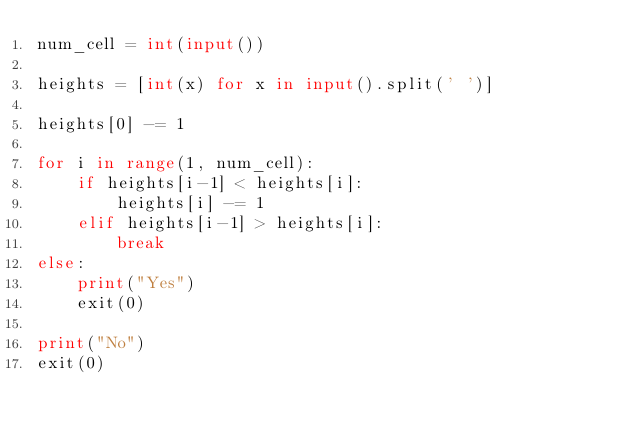Convert code to text. <code><loc_0><loc_0><loc_500><loc_500><_Python_>num_cell = int(input())

heights = [int(x) for x in input().split(' ')]

heights[0] -= 1

for i in range(1, num_cell):
    if heights[i-1] < heights[i]:
        heights[i] -= 1
    elif heights[i-1] > heights[i]:
        break
else:
    print("Yes")
    exit(0)

print("No")
exit(0)
</code> 